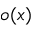<formula> <loc_0><loc_0><loc_500><loc_500>o ( x )</formula> 